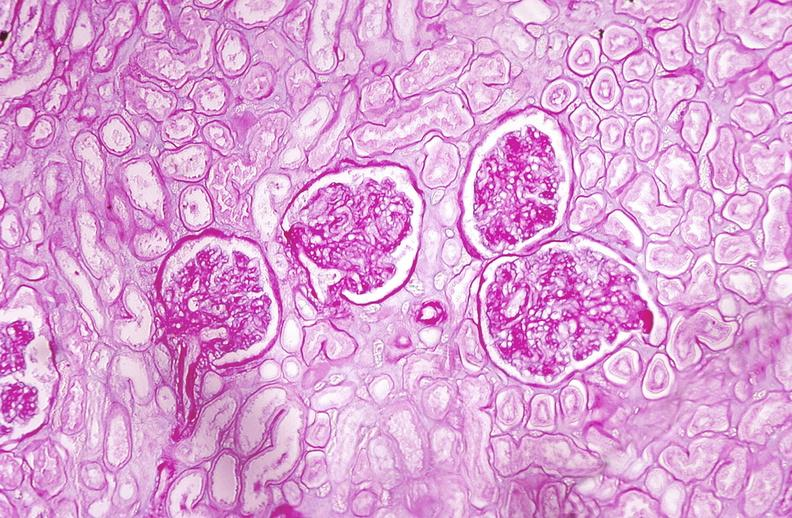where is this?
Answer the question using a single word or phrase. Urinary 